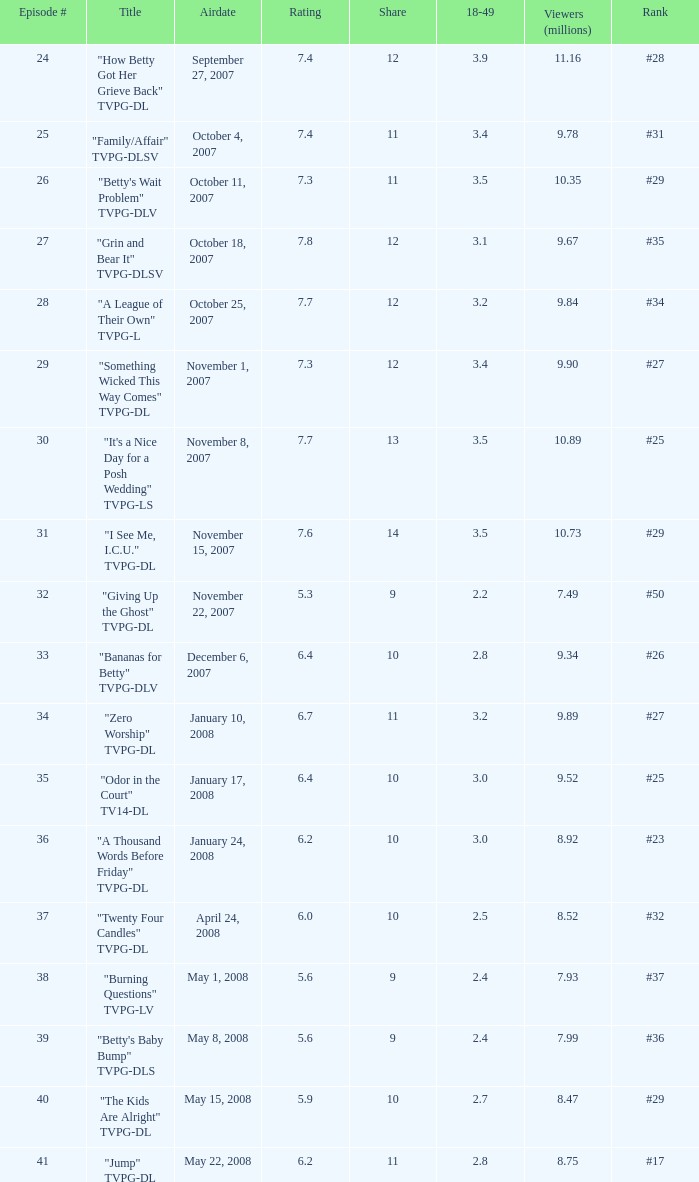What is the broadcast date of the episode that ranked #29 and had a share higher than 10? May 15, 2008. 